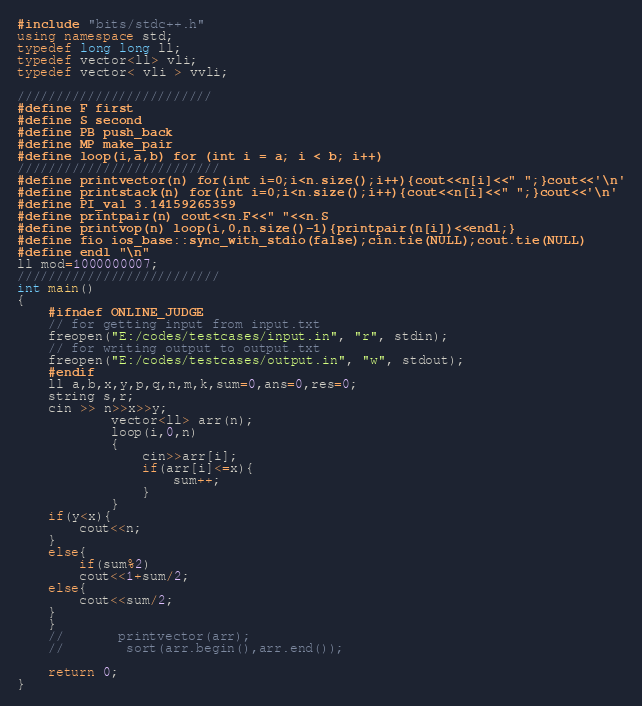<code> <loc_0><loc_0><loc_500><loc_500><_C++_>#include "bits/stdc++.h"
using namespace std;
typedef long long ll;
typedef vector<ll> vli; 
typedef vector< vli > vvli;

/////////////////////////
#define F first
#define S second
#define PB push_back
#define MP make_pair
#define loop(i,a,b) for (int i = a; i < b; i++)
//////////////////////////
#define printvector(n) for(int i=0;i<n.size();i++){cout<<n[i]<<" ";}cout<<'\n'
#define printstack(n) for(int i=0;i<n.size();i++){cout<<n[i]<<" ";}cout<<'\n'
#define PI_val 3.14159265359
#define printpair(n) cout<<n.F<<" "<<n.S
#define printvop(n) loop(i,0,n.size()-1){printpair(n[i])<<endl;}
#define fio ios_base::sync_with_stdio(false);cin.tie(NULL);cout.tie(NULL)
#define endl "\n"
ll mod=1000000007;
//////////////////////////
int main()
{
    #ifndef ONLINE_JUDGE
    // for getting input from input.txt
    freopen("E:/codes/testcases/input.in", "r", stdin);
    // for writing output to output.txt
    freopen("E:/codes/testcases/output.in", "w", stdout);
    #endif
    ll a,b,x,y,p,q,n,m,k,sum=0,ans=0,res=0;
    string s,r;
    cin >> n>>x>>y;
            vector<ll> arr(n);
            loop(i,0,n)
            {
                cin>>arr[i];
                if(arr[i]<=x){
                    sum++;
                }
            }
    if(y<x){
        cout<<n;
    }        
    else{
        if(sum%2)
        cout<<1+sum/2;
    else{
        cout<<sum/2;
    }
    }
    //       printvector(arr);
    //        sort(arr.begin(),arr.end());
    
    return 0;
}</code> 